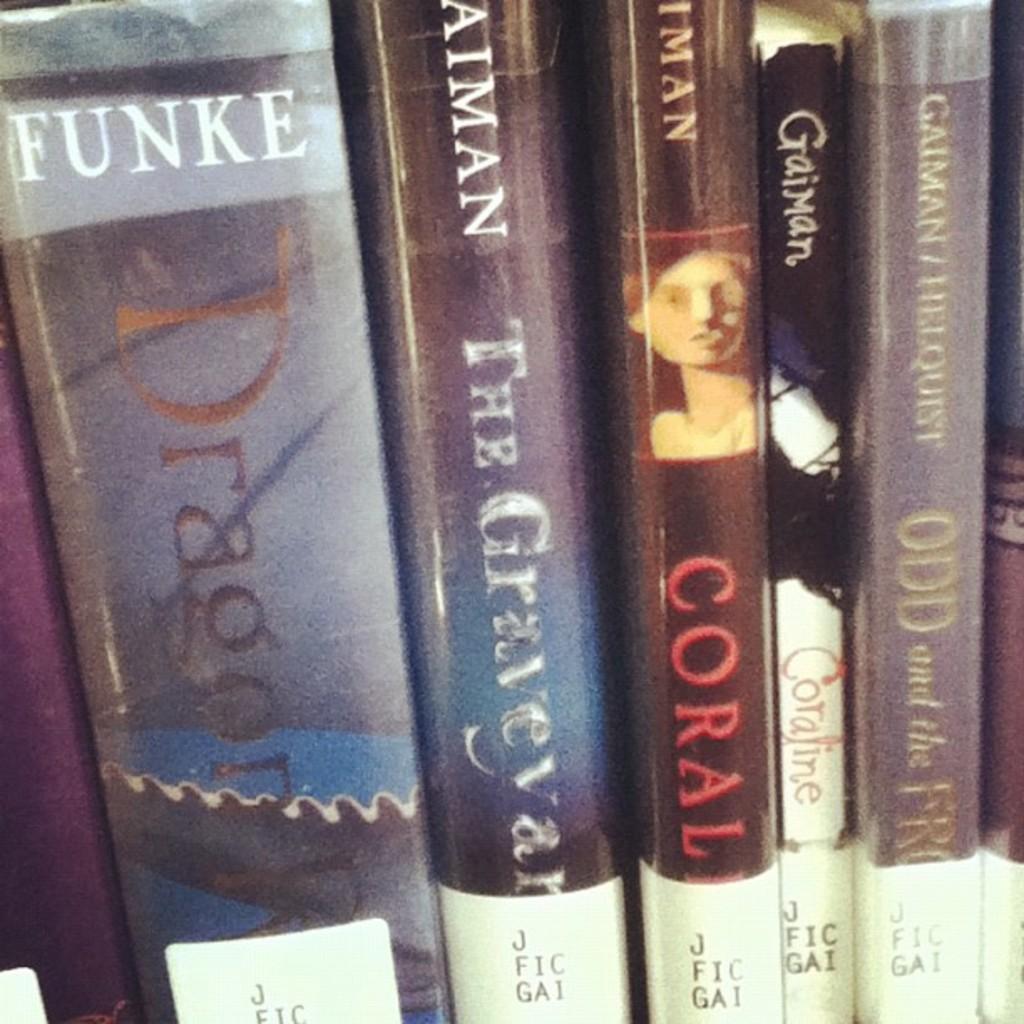What is the last name of the author who wrote the book dragon.?
Provide a short and direct response. Funke. 